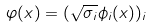Convert formula to latex. <formula><loc_0><loc_0><loc_500><loc_500>\varphi ( x ) = ( { \sqrt { \sigma _ { i } } } \phi _ { i } ( x ) ) _ { i }</formula> 